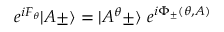Convert formula to latex. <formula><loc_0><loc_0><loc_500><loc_500>e ^ { i F _ { \theta } } | A \pm \rangle = | A ^ { \theta } \pm \rangle \ e ^ { i \Phi _ { \pm } ( \theta , A ) }</formula> 